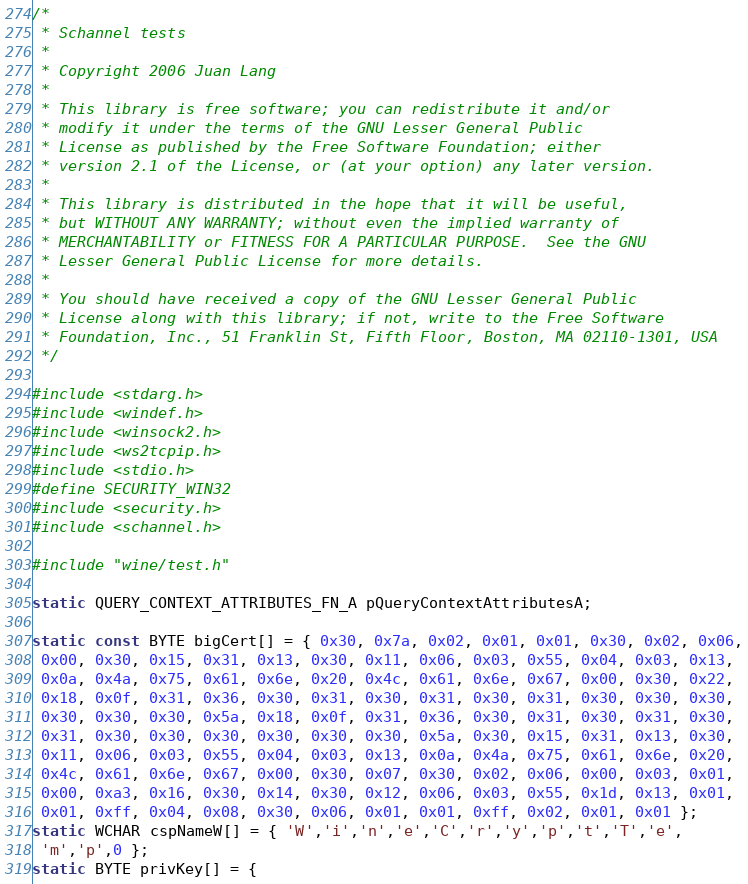<code> <loc_0><loc_0><loc_500><loc_500><_C_>/*
 * Schannel tests
 *
 * Copyright 2006 Juan Lang
 *
 * This library is free software; you can redistribute it and/or
 * modify it under the terms of the GNU Lesser General Public
 * License as published by the Free Software Foundation; either
 * version 2.1 of the License, or (at your option) any later version.
 *
 * This library is distributed in the hope that it will be useful,
 * but WITHOUT ANY WARRANTY; without even the implied warranty of
 * MERCHANTABILITY or FITNESS FOR A PARTICULAR PURPOSE.  See the GNU
 * Lesser General Public License for more details.
 *
 * You should have received a copy of the GNU Lesser General Public
 * License along with this library; if not, write to the Free Software
 * Foundation, Inc., 51 Franklin St, Fifth Floor, Boston, MA 02110-1301, USA
 */

#include <stdarg.h>
#include <windef.h>
#include <winsock2.h>
#include <ws2tcpip.h>
#include <stdio.h>
#define SECURITY_WIN32
#include <security.h>
#include <schannel.h>

#include "wine/test.h"

static QUERY_CONTEXT_ATTRIBUTES_FN_A pQueryContextAttributesA;

static const BYTE bigCert[] = { 0x30, 0x7a, 0x02, 0x01, 0x01, 0x30, 0x02, 0x06,
 0x00, 0x30, 0x15, 0x31, 0x13, 0x30, 0x11, 0x06, 0x03, 0x55, 0x04, 0x03, 0x13,
 0x0a, 0x4a, 0x75, 0x61, 0x6e, 0x20, 0x4c, 0x61, 0x6e, 0x67, 0x00, 0x30, 0x22,
 0x18, 0x0f, 0x31, 0x36, 0x30, 0x31, 0x30, 0x31, 0x30, 0x31, 0x30, 0x30, 0x30,
 0x30, 0x30, 0x30, 0x5a, 0x18, 0x0f, 0x31, 0x36, 0x30, 0x31, 0x30, 0x31, 0x30,
 0x31, 0x30, 0x30, 0x30, 0x30, 0x30, 0x30, 0x5a, 0x30, 0x15, 0x31, 0x13, 0x30,
 0x11, 0x06, 0x03, 0x55, 0x04, 0x03, 0x13, 0x0a, 0x4a, 0x75, 0x61, 0x6e, 0x20,
 0x4c, 0x61, 0x6e, 0x67, 0x00, 0x30, 0x07, 0x30, 0x02, 0x06, 0x00, 0x03, 0x01,
 0x00, 0xa3, 0x16, 0x30, 0x14, 0x30, 0x12, 0x06, 0x03, 0x55, 0x1d, 0x13, 0x01,
 0x01, 0xff, 0x04, 0x08, 0x30, 0x06, 0x01, 0x01, 0xff, 0x02, 0x01, 0x01 };
static WCHAR cspNameW[] = { 'W','i','n','e','C','r','y','p','t','T','e',
 'm','p',0 };
static BYTE privKey[] = {</code> 